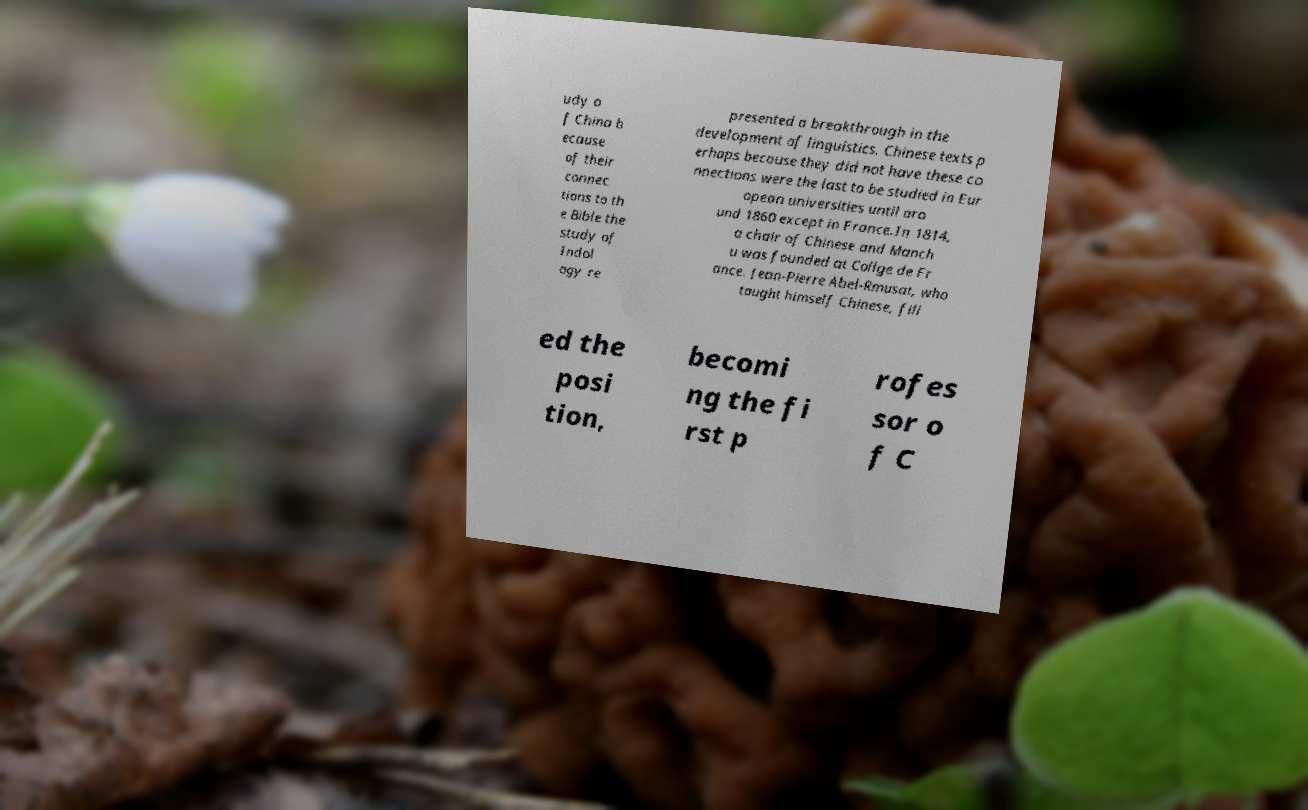Please identify and transcribe the text found in this image. udy o f China b ecause of their connec tions to th e Bible the study of Indol ogy re presented a breakthrough in the development of linguistics. Chinese texts p erhaps because they did not have these co nnections were the last to be studied in Eur opean universities until aro und 1860 except in France.In 1814, a chair of Chinese and Manch u was founded at Collge de Fr ance. Jean-Pierre Abel-Rmusat, who taught himself Chinese, fill ed the posi tion, becomi ng the fi rst p rofes sor o f C 